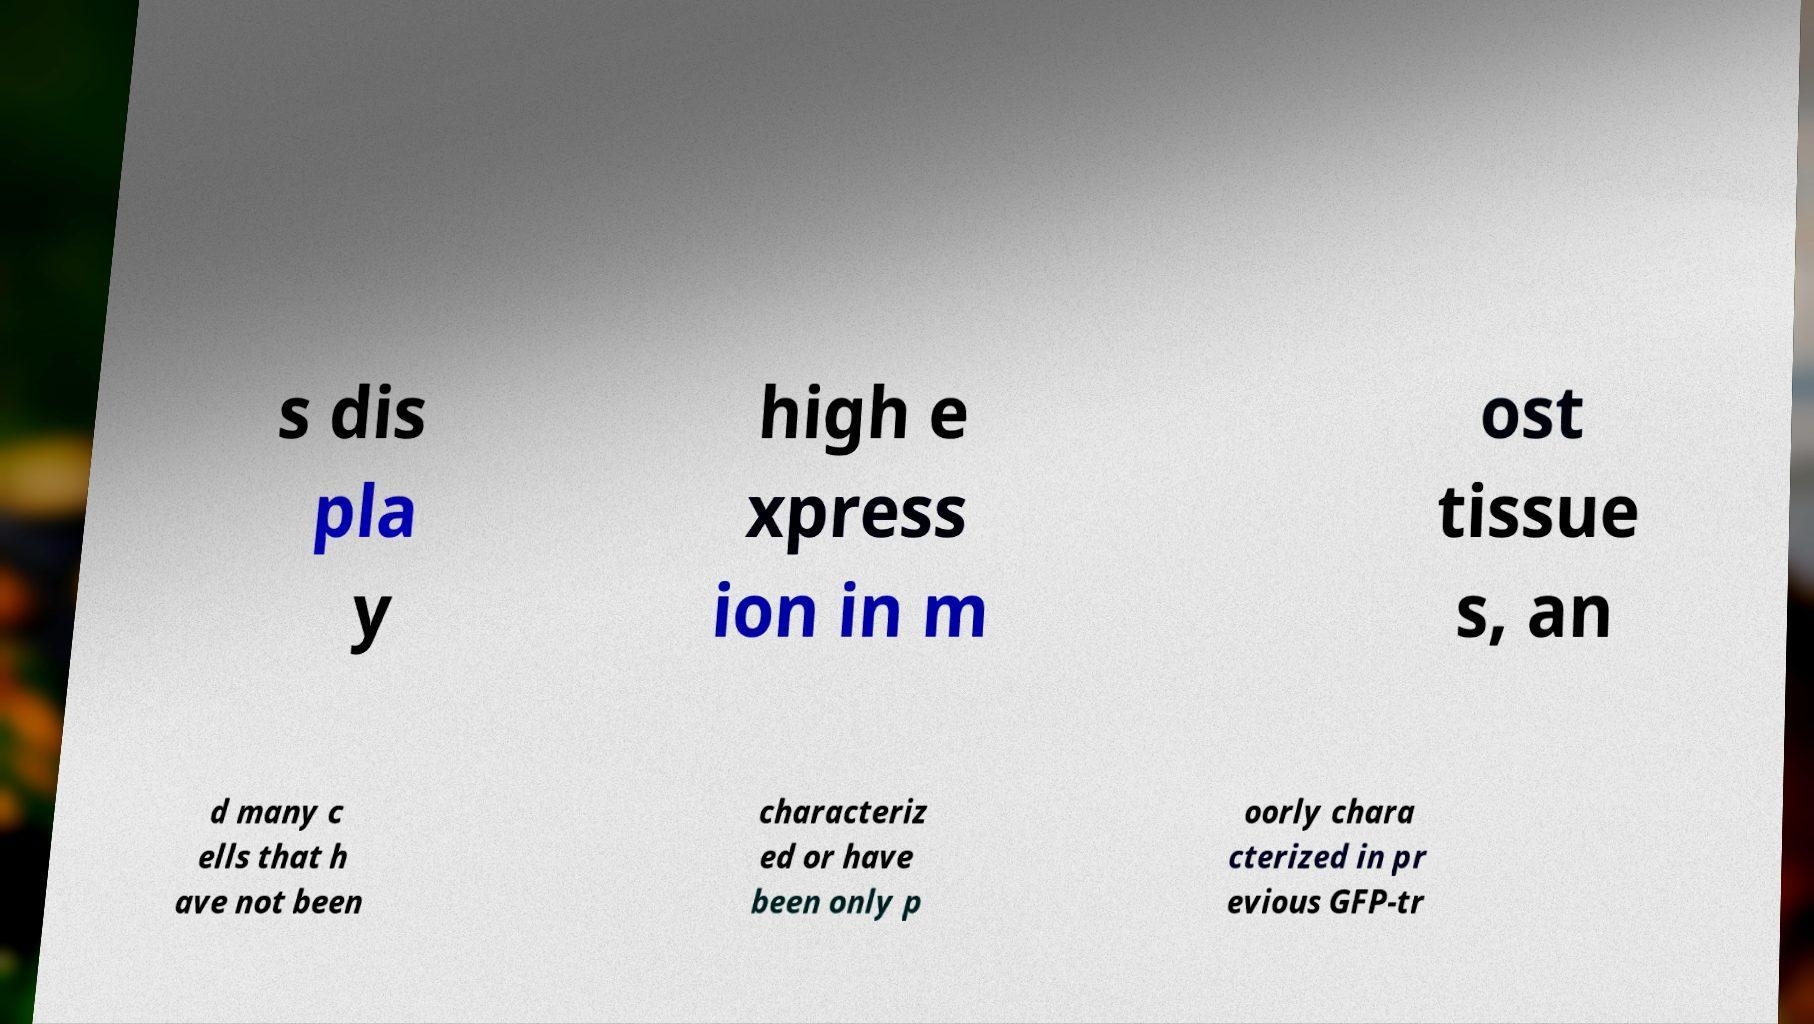Please read and relay the text visible in this image. What does it say? s dis pla y high e xpress ion in m ost tissue s, an d many c ells that h ave not been characteriz ed or have been only p oorly chara cterized in pr evious GFP-tr 